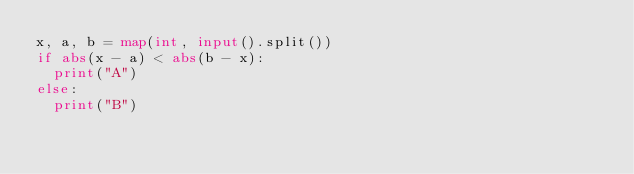<code> <loc_0><loc_0><loc_500><loc_500><_Python_>x, a, b = map(int, input().split())
if abs(x - a) < abs(b - x):
	print("A")
else:
	print("B")
</code> 